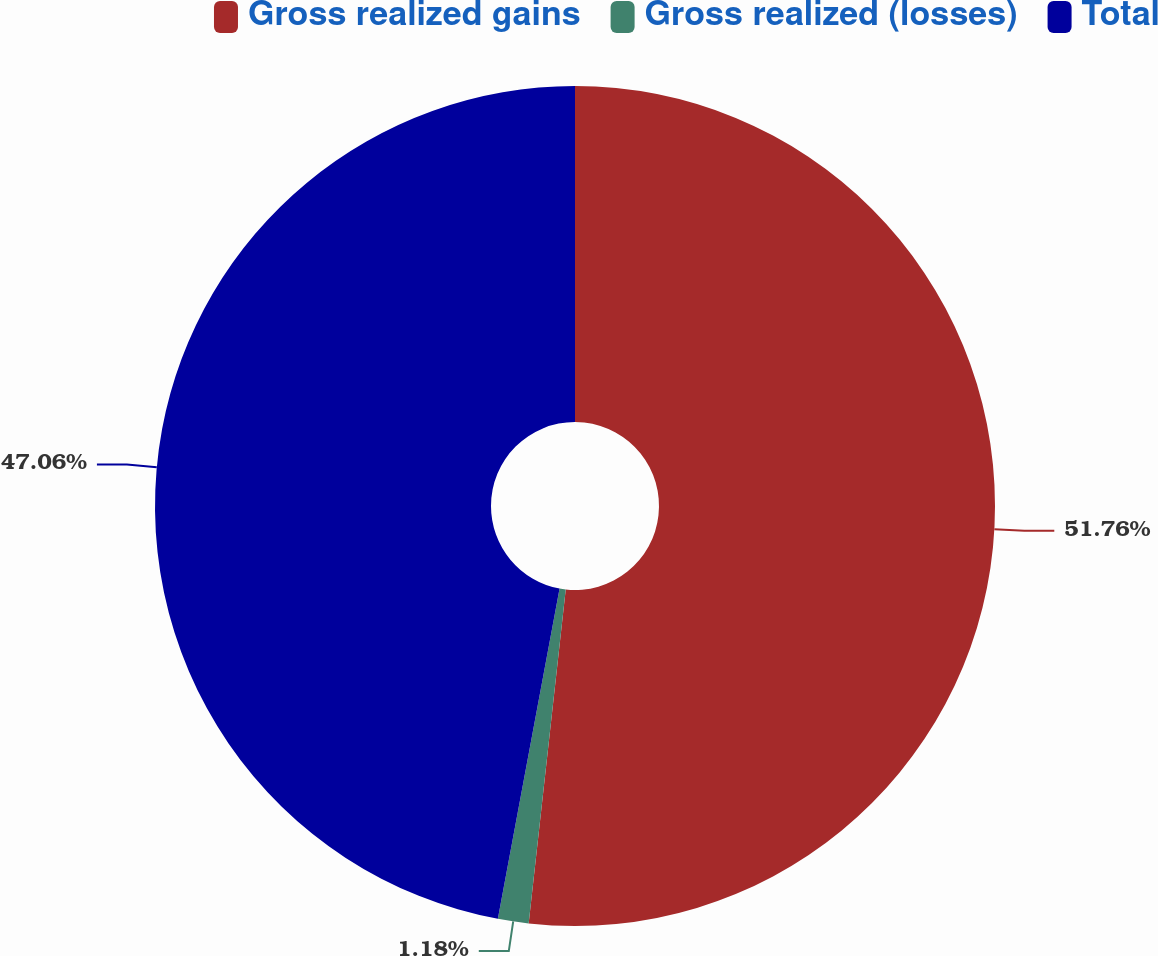Convert chart. <chart><loc_0><loc_0><loc_500><loc_500><pie_chart><fcel>Gross realized gains<fcel>Gross realized (losses)<fcel>Total<nl><fcel>51.76%<fcel>1.18%<fcel>47.06%<nl></chart> 